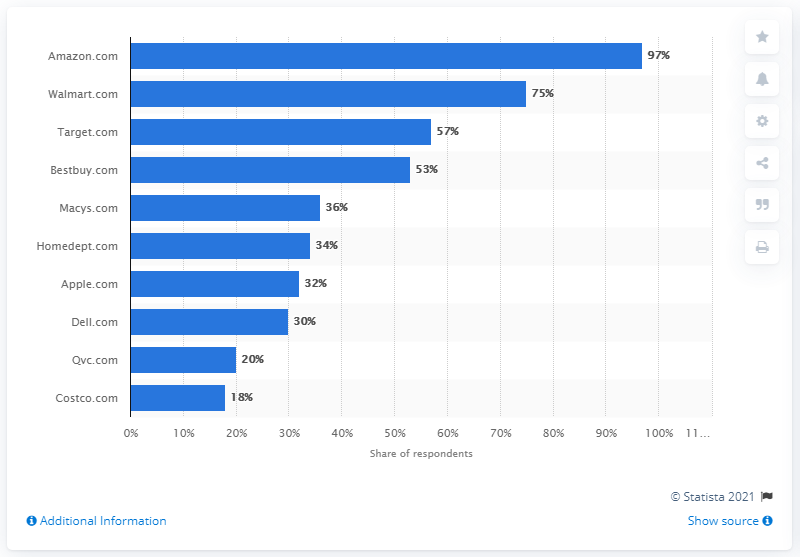Point out several critical features in this image. According to the survey results, 97% of respondents reported having purchased from Amazon.com at least once. 